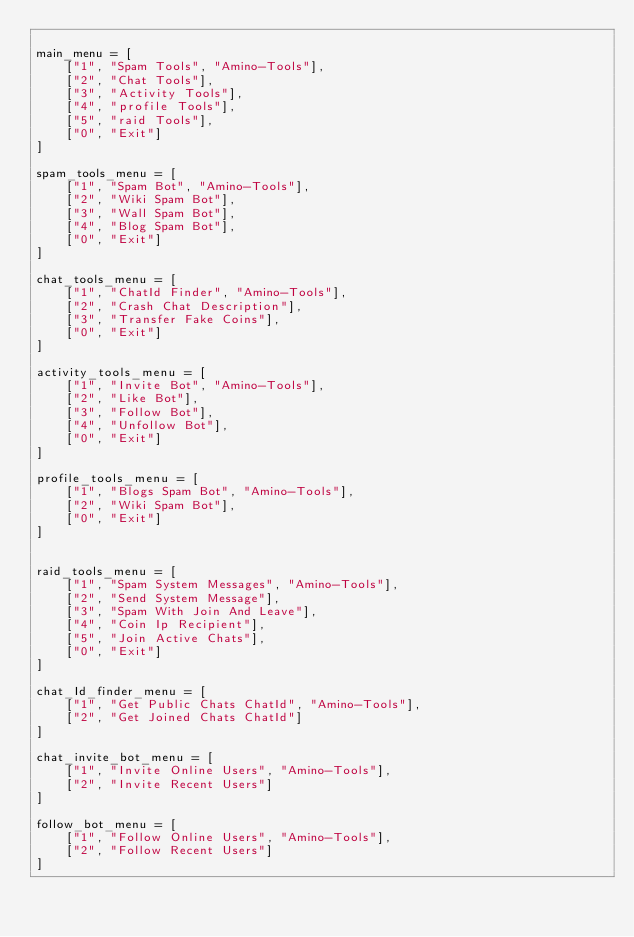<code> <loc_0><loc_0><loc_500><loc_500><_Python_>
main_menu = [
	["1", "Spam Tools", "Amino-Tools"],
	["2", "Chat Tools"],
	["3", "Activity Tools"],
	["4", "profile Tools"],
	["5", "raid Tools"],
	["0", "Exit"]
]

spam_tools_menu = [ 
	["1", "Spam Bot", "Amino-Tools"],
	["2", "Wiki Spam Bot"],
	["3", "Wall Spam Bot"],
	["4", "Blog Spam Bot"],
	["0", "Exit"]
]

chat_tools_menu = [
	["1", "ChatId Finder", "Amino-Tools"],
	["2", "Crash Chat Description"],
	["3", "Transfer Fake Coins"],
	["0", "Exit"]
]

activity_tools_menu = [
	["1", "Invite Bot", "Amino-Tools"],
	["2", "Like Bot"],
	["3", "Follow Bot"],
	["4", "Unfollow Bot"],
	["0", "Exit"]
]

profile_tools_menu = [
	["1", "Blogs Spam Bot", "Amino-Tools"],
	["2", "Wiki Spam Bot"],
	["0", "Exit"]
]


raid_tools_menu = [
	["1", "Spam System Messages", "Amino-Tools"],
	["2", "Send System Message"],
	["3", "Spam With Join And Leave"],
	["4", "Coin Ip Recipient"],
	["5", "Join Active Chats"],
	["0", "Exit"]
]

chat_Id_finder_menu = [
	["1", "Get Public Chats ChatId", "Amino-Tools"],
	["2", "Get Joined Chats ChatId"]
]

chat_invite_bot_menu = [
	["1", "Invite Online Users", "Amino-Tools"],
	["2", "Invite Recent Users"]
]

follow_bot_menu = [
	["1", "Follow Online Users", "Amino-Tools"],
	["2", "Follow Recent Users"]
]
</code> 